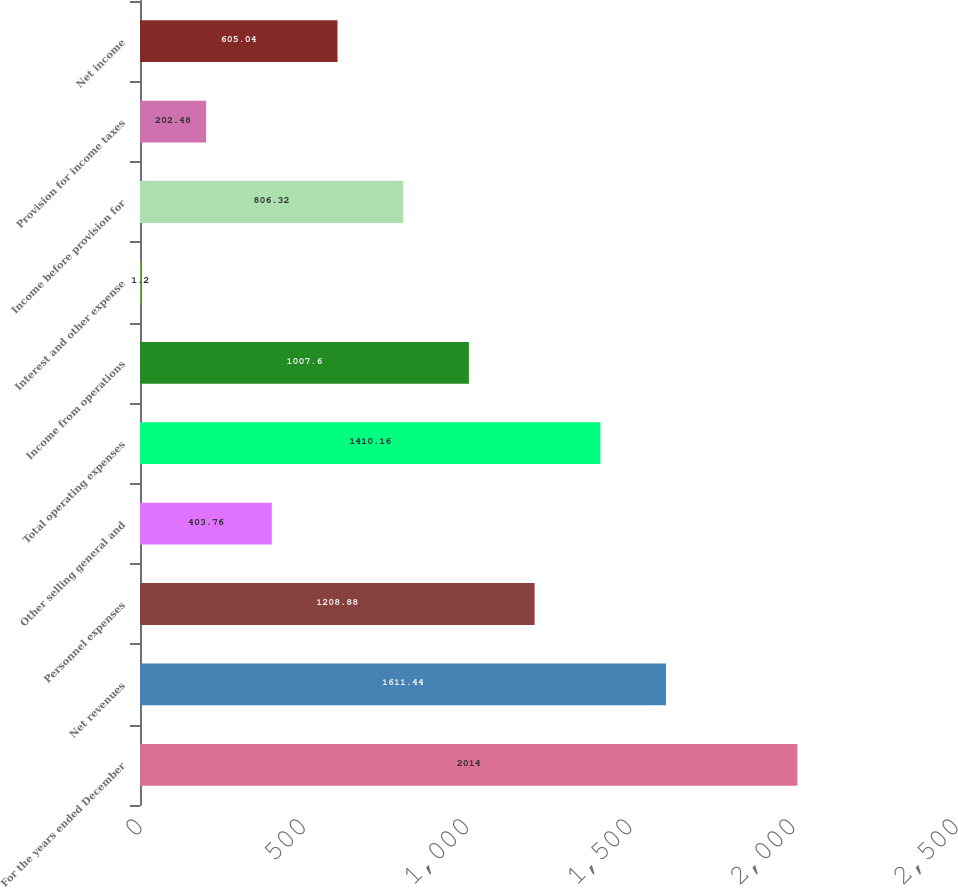<chart> <loc_0><loc_0><loc_500><loc_500><bar_chart><fcel>For the years ended December<fcel>Net revenues<fcel>Personnel expenses<fcel>Other selling general and<fcel>Total operating expenses<fcel>Income from operations<fcel>Interest and other expense<fcel>Income before provision for<fcel>Provision for income taxes<fcel>Net income<nl><fcel>2014<fcel>1611.44<fcel>1208.88<fcel>403.76<fcel>1410.16<fcel>1007.6<fcel>1.2<fcel>806.32<fcel>202.48<fcel>605.04<nl></chart> 